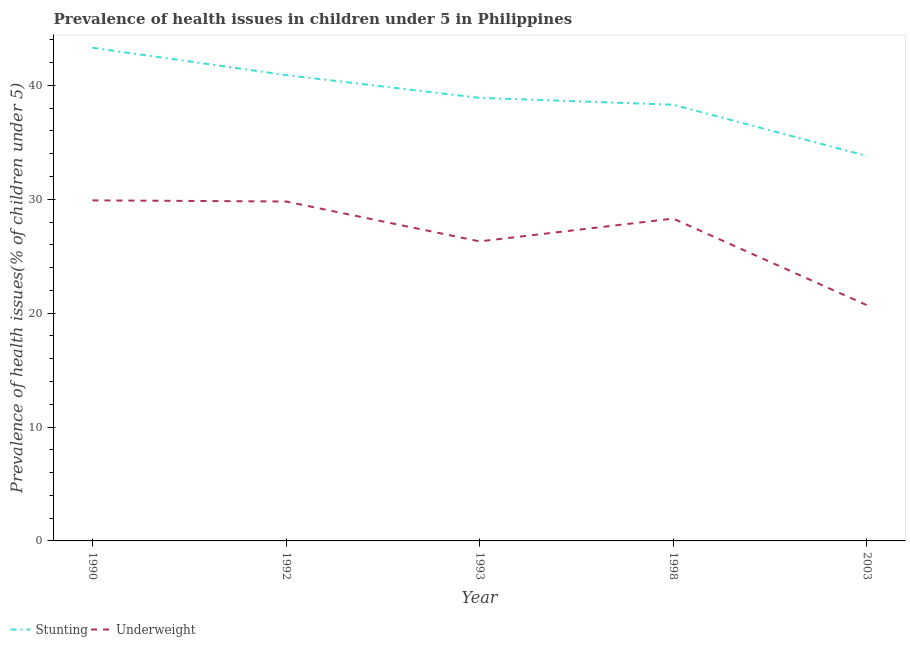How many different coloured lines are there?
Offer a very short reply. 2. What is the percentage of stunted children in 1993?
Your response must be concise. 38.9. Across all years, what is the maximum percentage of underweight children?
Offer a terse response. 29.9. Across all years, what is the minimum percentage of stunted children?
Provide a succinct answer. 33.8. In which year was the percentage of underweight children minimum?
Make the answer very short. 2003. What is the total percentage of underweight children in the graph?
Your response must be concise. 135. What is the difference between the percentage of stunted children in 1993 and that in 2003?
Provide a succinct answer. 5.1. What is the difference between the percentage of underweight children in 2003 and the percentage of stunted children in 1998?
Your answer should be very brief. -17.6. What is the average percentage of underweight children per year?
Offer a very short reply. 27. In the year 1998, what is the difference between the percentage of underweight children and percentage of stunted children?
Give a very brief answer. -10. In how many years, is the percentage of stunted children greater than 20 %?
Your answer should be very brief. 5. What is the ratio of the percentage of stunted children in 1990 to that in 2003?
Your answer should be very brief. 1.28. What is the difference between the highest and the second highest percentage of underweight children?
Your answer should be compact. 0.1. What is the difference between the highest and the lowest percentage of stunted children?
Your answer should be very brief. 9.5. In how many years, is the percentage of stunted children greater than the average percentage of stunted children taken over all years?
Offer a very short reply. 2. Does the percentage of underweight children monotonically increase over the years?
Your response must be concise. No. Is the percentage of stunted children strictly greater than the percentage of underweight children over the years?
Offer a terse response. Yes. What is the difference between two consecutive major ticks on the Y-axis?
Give a very brief answer. 10. Are the values on the major ticks of Y-axis written in scientific E-notation?
Your answer should be compact. No. Does the graph contain grids?
Your answer should be very brief. No. Where does the legend appear in the graph?
Make the answer very short. Bottom left. How many legend labels are there?
Offer a terse response. 2. How are the legend labels stacked?
Your answer should be compact. Horizontal. What is the title of the graph?
Offer a very short reply. Prevalence of health issues in children under 5 in Philippines. What is the label or title of the Y-axis?
Offer a terse response. Prevalence of health issues(% of children under 5). What is the Prevalence of health issues(% of children under 5) in Stunting in 1990?
Keep it short and to the point. 43.3. What is the Prevalence of health issues(% of children under 5) of Underweight in 1990?
Your answer should be very brief. 29.9. What is the Prevalence of health issues(% of children under 5) in Stunting in 1992?
Offer a very short reply. 40.9. What is the Prevalence of health issues(% of children under 5) in Underweight in 1992?
Make the answer very short. 29.8. What is the Prevalence of health issues(% of children under 5) of Stunting in 1993?
Your answer should be very brief. 38.9. What is the Prevalence of health issues(% of children under 5) in Underweight in 1993?
Your answer should be very brief. 26.3. What is the Prevalence of health issues(% of children under 5) in Stunting in 1998?
Keep it short and to the point. 38.3. What is the Prevalence of health issues(% of children under 5) in Underweight in 1998?
Provide a succinct answer. 28.3. What is the Prevalence of health issues(% of children under 5) of Stunting in 2003?
Offer a very short reply. 33.8. What is the Prevalence of health issues(% of children under 5) in Underweight in 2003?
Provide a short and direct response. 20.7. Across all years, what is the maximum Prevalence of health issues(% of children under 5) of Stunting?
Offer a very short reply. 43.3. Across all years, what is the maximum Prevalence of health issues(% of children under 5) in Underweight?
Your response must be concise. 29.9. Across all years, what is the minimum Prevalence of health issues(% of children under 5) of Stunting?
Your response must be concise. 33.8. Across all years, what is the minimum Prevalence of health issues(% of children under 5) in Underweight?
Keep it short and to the point. 20.7. What is the total Prevalence of health issues(% of children under 5) of Stunting in the graph?
Your answer should be compact. 195.2. What is the total Prevalence of health issues(% of children under 5) in Underweight in the graph?
Offer a terse response. 135. What is the difference between the Prevalence of health issues(% of children under 5) of Underweight in 1990 and that in 1992?
Provide a short and direct response. 0.1. What is the difference between the Prevalence of health issues(% of children under 5) of Stunting in 1990 and that in 1993?
Make the answer very short. 4.4. What is the difference between the Prevalence of health issues(% of children under 5) of Underweight in 1990 and that in 1998?
Keep it short and to the point. 1.6. What is the difference between the Prevalence of health issues(% of children under 5) in Stunting in 1990 and that in 2003?
Make the answer very short. 9.5. What is the difference between the Prevalence of health issues(% of children under 5) in Stunting in 1992 and that in 1993?
Offer a terse response. 2. What is the difference between the Prevalence of health issues(% of children under 5) of Stunting in 1992 and that in 1998?
Ensure brevity in your answer.  2.6. What is the difference between the Prevalence of health issues(% of children under 5) in Stunting in 1992 and that in 2003?
Offer a very short reply. 7.1. What is the difference between the Prevalence of health issues(% of children under 5) in Underweight in 1993 and that in 1998?
Ensure brevity in your answer.  -2. What is the difference between the Prevalence of health issues(% of children under 5) of Underweight in 1993 and that in 2003?
Make the answer very short. 5.6. What is the difference between the Prevalence of health issues(% of children under 5) of Stunting in 1998 and that in 2003?
Your answer should be very brief. 4.5. What is the difference between the Prevalence of health issues(% of children under 5) of Underweight in 1998 and that in 2003?
Your answer should be very brief. 7.6. What is the difference between the Prevalence of health issues(% of children under 5) of Stunting in 1990 and the Prevalence of health issues(% of children under 5) of Underweight in 1992?
Offer a terse response. 13.5. What is the difference between the Prevalence of health issues(% of children under 5) of Stunting in 1990 and the Prevalence of health issues(% of children under 5) of Underweight in 2003?
Ensure brevity in your answer.  22.6. What is the difference between the Prevalence of health issues(% of children under 5) of Stunting in 1992 and the Prevalence of health issues(% of children under 5) of Underweight in 1998?
Ensure brevity in your answer.  12.6. What is the difference between the Prevalence of health issues(% of children under 5) in Stunting in 1992 and the Prevalence of health issues(% of children under 5) in Underweight in 2003?
Provide a short and direct response. 20.2. What is the difference between the Prevalence of health issues(% of children under 5) in Stunting in 1993 and the Prevalence of health issues(% of children under 5) in Underweight in 2003?
Offer a very short reply. 18.2. What is the difference between the Prevalence of health issues(% of children under 5) of Stunting in 1998 and the Prevalence of health issues(% of children under 5) of Underweight in 2003?
Your response must be concise. 17.6. What is the average Prevalence of health issues(% of children under 5) of Stunting per year?
Provide a short and direct response. 39.04. What is the average Prevalence of health issues(% of children under 5) in Underweight per year?
Your response must be concise. 27. In the year 1993, what is the difference between the Prevalence of health issues(% of children under 5) in Stunting and Prevalence of health issues(% of children under 5) in Underweight?
Your answer should be compact. 12.6. In the year 1998, what is the difference between the Prevalence of health issues(% of children under 5) of Stunting and Prevalence of health issues(% of children under 5) of Underweight?
Your response must be concise. 10. In the year 2003, what is the difference between the Prevalence of health issues(% of children under 5) of Stunting and Prevalence of health issues(% of children under 5) of Underweight?
Your response must be concise. 13.1. What is the ratio of the Prevalence of health issues(% of children under 5) of Stunting in 1990 to that in 1992?
Make the answer very short. 1.06. What is the ratio of the Prevalence of health issues(% of children under 5) in Stunting in 1990 to that in 1993?
Ensure brevity in your answer.  1.11. What is the ratio of the Prevalence of health issues(% of children under 5) of Underweight in 1990 to that in 1993?
Provide a succinct answer. 1.14. What is the ratio of the Prevalence of health issues(% of children under 5) in Stunting in 1990 to that in 1998?
Your answer should be compact. 1.13. What is the ratio of the Prevalence of health issues(% of children under 5) in Underweight in 1990 to that in 1998?
Your response must be concise. 1.06. What is the ratio of the Prevalence of health issues(% of children under 5) in Stunting in 1990 to that in 2003?
Your answer should be very brief. 1.28. What is the ratio of the Prevalence of health issues(% of children under 5) in Underweight in 1990 to that in 2003?
Give a very brief answer. 1.44. What is the ratio of the Prevalence of health issues(% of children under 5) of Stunting in 1992 to that in 1993?
Provide a succinct answer. 1.05. What is the ratio of the Prevalence of health issues(% of children under 5) in Underweight in 1992 to that in 1993?
Offer a terse response. 1.13. What is the ratio of the Prevalence of health issues(% of children under 5) of Stunting in 1992 to that in 1998?
Give a very brief answer. 1.07. What is the ratio of the Prevalence of health issues(% of children under 5) in Underweight in 1992 to that in 1998?
Offer a very short reply. 1.05. What is the ratio of the Prevalence of health issues(% of children under 5) in Stunting in 1992 to that in 2003?
Provide a short and direct response. 1.21. What is the ratio of the Prevalence of health issues(% of children under 5) in Underweight in 1992 to that in 2003?
Provide a short and direct response. 1.44. What is the ratio of the Prevalence of health issues(% of children under 5) of Stunting in 1993 to that in 1998?
Ensure brevity in your answer.  1.02. What is the ratio of the Prevalence of health issues(% of children under 5) in Underweight in 1993 to that in 1998?
Make the answer very short. 0.93. What is the ratio of the Prevalence of health issues(% of children under 5) of Stunting in 1993 to that in 2003?
Your answer should be compact. 1.15. What is the ratio of the Prevalence of health issues(% of children under 5) of Underweight in 1993 to that in 2003?
Ensure brevity in your answer.  1.27. What is the ratio of the Prevalence of health issues(% of children under 5) in Stunting in 1998 to that in 2003?
Give a very brief answer. 1.13. What is the ratio of the Prevalence of health issues(% of children under 5) in Underweight in 1998 to that in 2003?
Your answer should be very brief. 1.37. What is the difference between the highest and the second highest Prevalence of health issues(% of children under 5) in Underweight?
Your answer should be very brief. 0.1. What is the difference between the highest and the lowest Prevalence of health issues(% of children under 5) in Underweight?
Your answer should be compact. 9.2. 